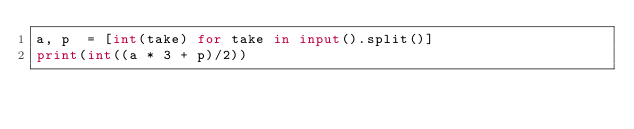Convert code to text. <code><loc_0><loc_0><loc_500><loc_500><_Python_>a, p  = [int(take) for take in input().split()]
print(int((a * 3 + p)/2))</code> 